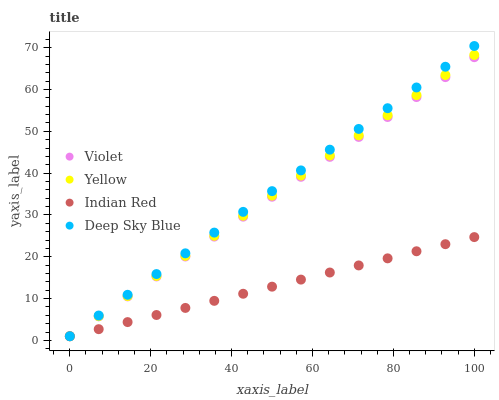Does Indian Red have the minimum area under the curve?
Answer yes or no. Yes. Does Deep Sky Blue have the maximum area under the curve?
Answer yes or no. Yes. Does Yellow have the minimum area under the curve?
Answer yes or no. No. Does Yellow have the maximum area under the curve?
Answer yes or no. No. Is Indian Red the smoothest?
Answer yes or no. Yes. Is Yellow the roughest?
Answer yes or no. Yes. Is Yellow the smoothest?
Answer yes or no. No. Is Indian Red the roughest?
Answer yes or no. No. Does Deep Sky Blue have the lowest value?
Answer yes or no. Yes. Does Deep Sky Blue have the highest value?
Answer yes or no. Yes. Does Yellow have the highest value?
Answer yes or no. No. Does Violet intersect Yellow?
Answer yes or no. Yes. Is Violet less than Yellow?
Answer yes or no. No. Is Violet greater than Yellow?
Answer yes or no. No. 